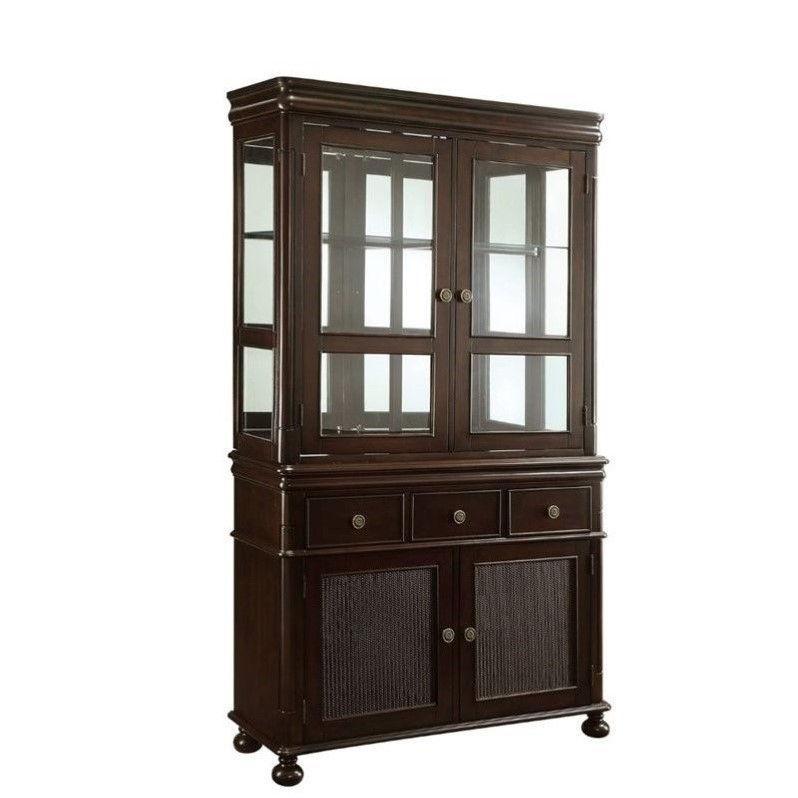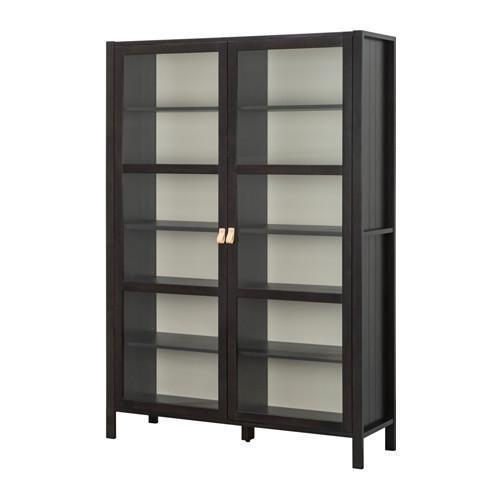The first image is the image on the left, the second image is the image on the right. For the images displayed, is the sentence "The cabinet in the image on the right is bare." factually correct? Answer yes or no. Yes. The first image is the image on the left, the second image is the image on the right. Considering the images on both sides, is "There is no less than one hutch that is completely empty" valid? Answer yes or no. Yes. 